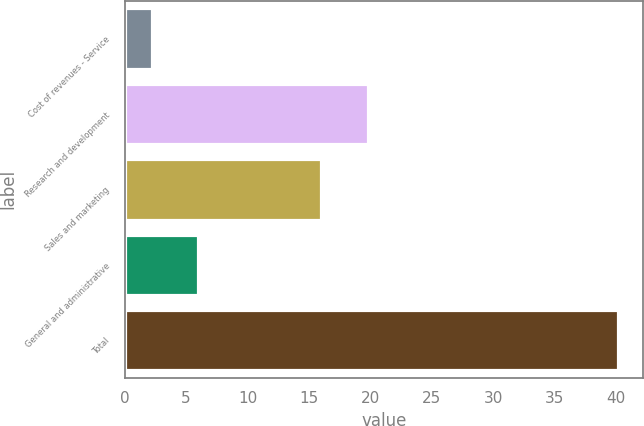Convert chart to OTSL. <chart><loc_0><loc_0><loc_500><loc_500><bar_chart><fcel>Cost of revenues - Service<fcel>Research and development<fcel>Sales and marketing<fcel>General and administrative<fcel>Total<nl><fcel>2.2<fcel>19.8<fcel>16<fcel>6<fcel>40.2<nl></chart> 